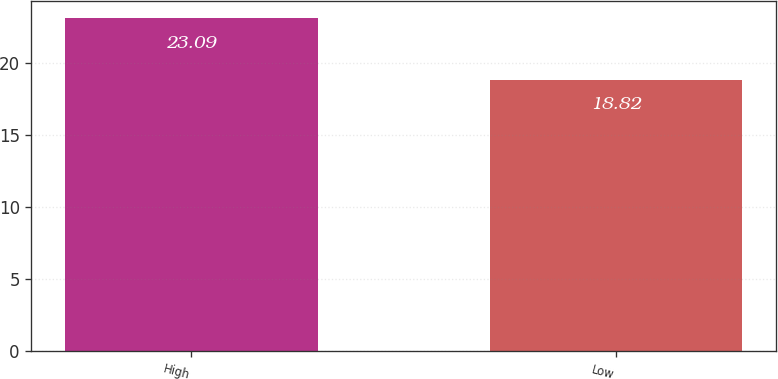<chart> <loc_0><loc_0><loc_500><loc_500><bar_chart><fcel>High<fcel>Low<nl><fcel>23.09<fcel>18.82<nl></chart> 